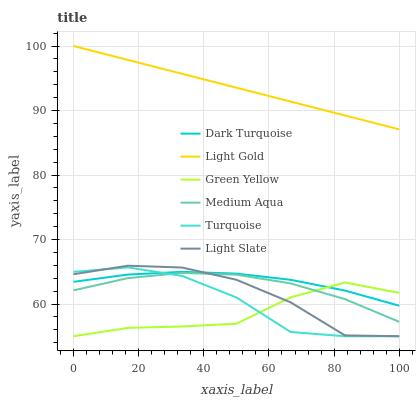Does Light Slate have the minimum area under the curve?
Answer yes or no. No. Does Light Slate have the maximum area under the curve?
Answer yes or no. No. Is Dark Turquoise the smoothest?
Answer yes or no. No. Is Dark Turquoise the roughest?
Answer yes or no. No. Does Dark Turquoise have the lowest value?
Answer yes or no. No. Does Light Slate have the highest value?
Answer yes or no. No. Is Light Slate less than Light Gold?
Answer yes or no. Yes. Is Dark Turquoise greater than Medium Aqua?
Answer yes or no. Yes. Does Light Slate intersect Light Gold?
Answer yes or no. No. 